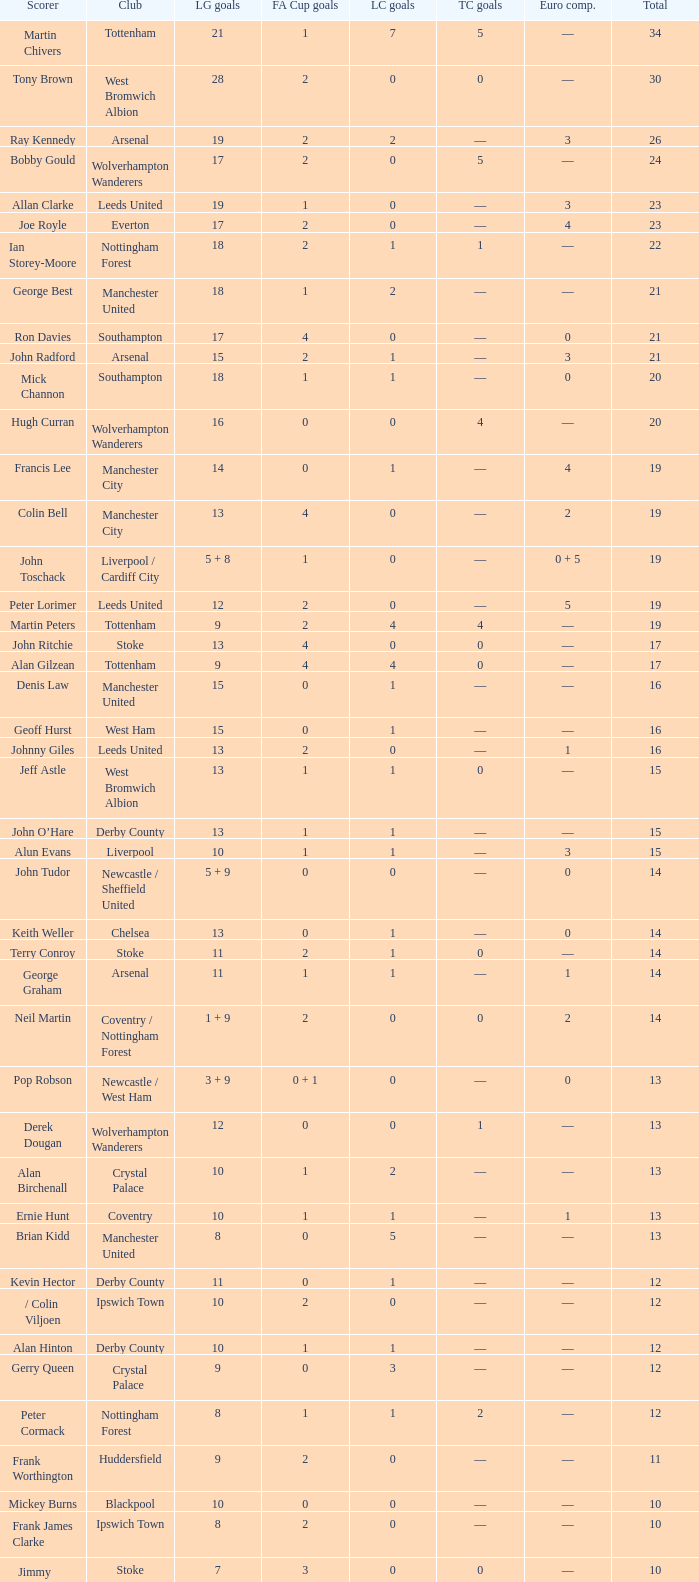What is the average Total, when FA Cup Goals is 1, when League Goals is 10, and when Club is Crystal Palace? 13.0. 